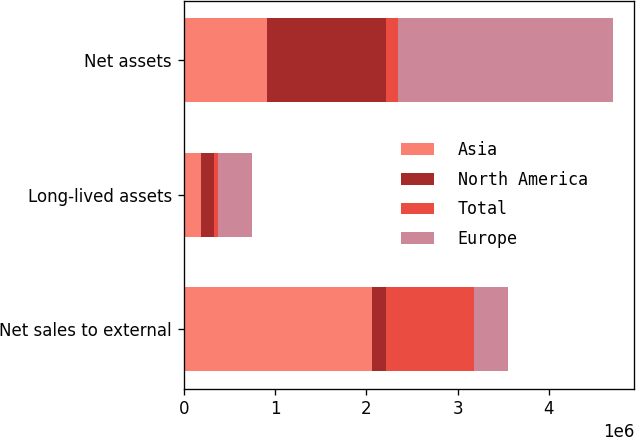Convert chart. <chart><loc_0><loc_0><loc_500><loc_500><stacked_bar_chart><ecel><fcel>Net sales to external<fcel>Long-lived assets<fcel>Net assets<nl><fcel>Asia<fcel>2.06682e+06<fcel>185838<fcel>908267<nl><fcel>North America<fcel>144155<fcel>143181<fcel>1.30978e+06<nl><fcel>Total<fcel>969341<fcel>45128<fcel>132564<nl><fcel>Europe<fcel>374147<fcel>374147<fcel>2.35061e+06<nl></chart> 